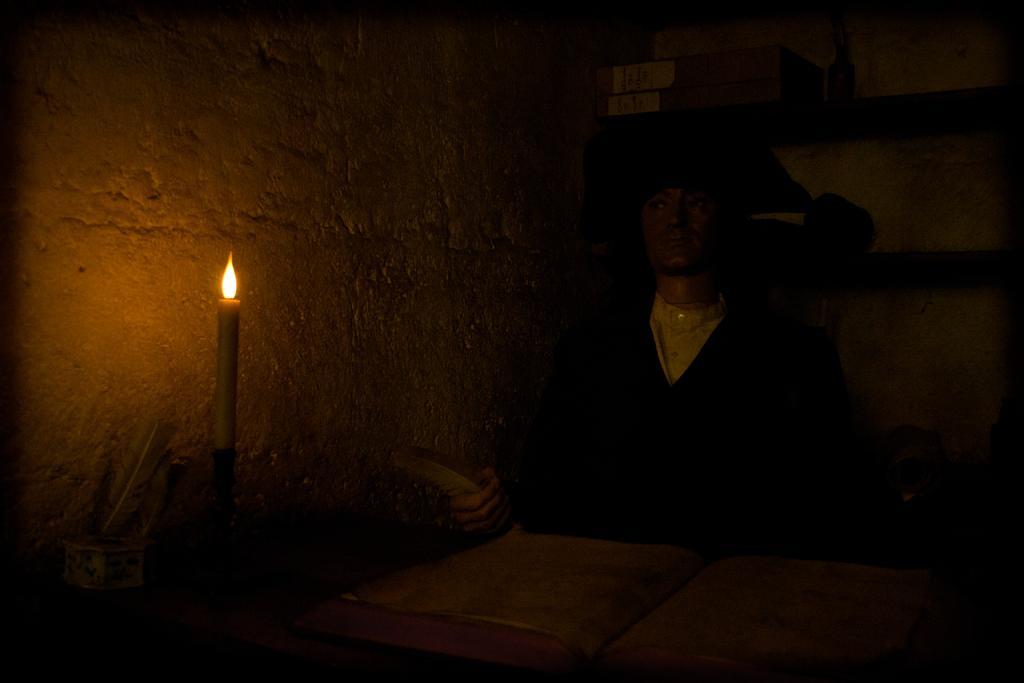Please provide a concise description of this image. In the image there is a statue sitting in front of a book and beside the book there is a wall and there is a candle in front of a wall and there is a feather in the hand of a statue. 